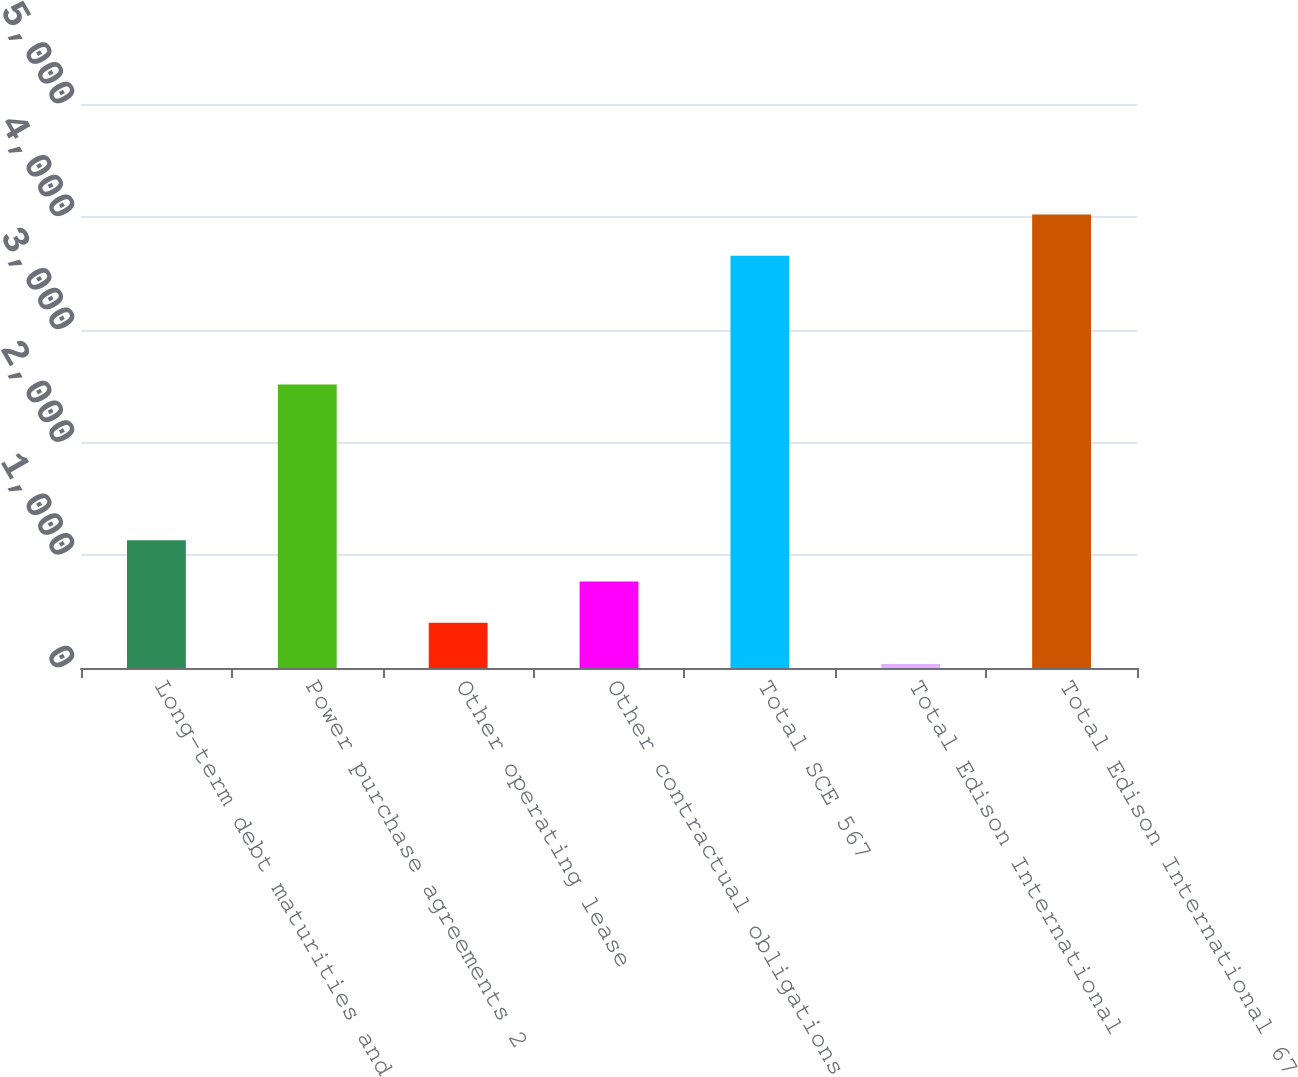Convert chart to OTSL. <chart><loc_0><loc_0><loc_500><loc_500><bar_chart><fcel>Long-term debt maturities and<fcel>Power purchase agreements 2<fcel>Other operating lease<fcel>Other contractual obligations<fcel>Total SCE 567<fcel>Total Edison International<fcel>Total Edison International 67<nl><fcel>1131.5<fcel>2513<fcel>400.5<fcel>766<fcel>3655<fcel>35<fcel>4020.5<nl></chart> 